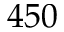Convert formula to latex. <formula><loc_0><loc_0><loc_500><loc_500>4 5 0</formula> 